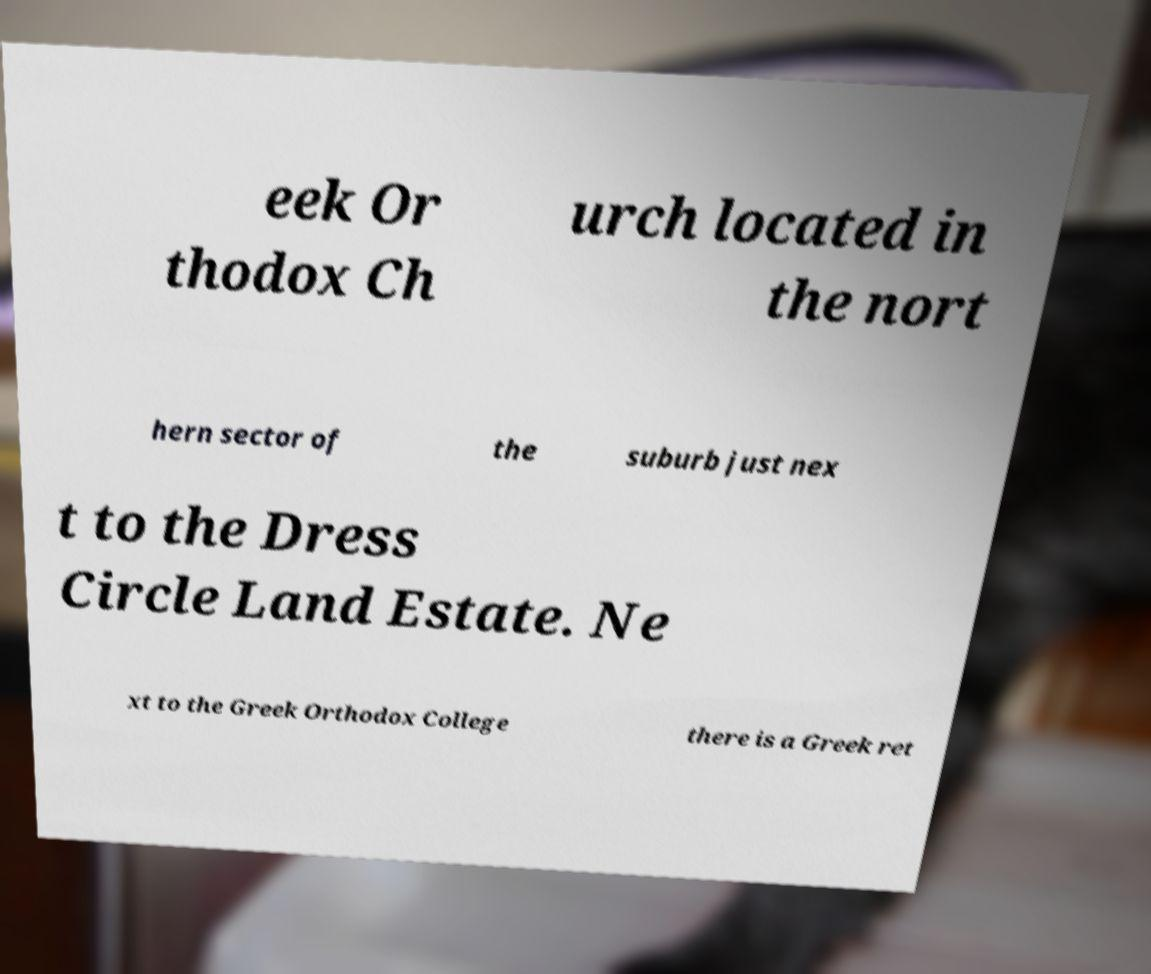Could you extract and type out the text from this image? eek Or thodox Ch urch located in the nort hern sector of the suburb just nex t to the Dress Circle Land Estate. Ne xt to the Greek Orthodox College there is a Greek ret 